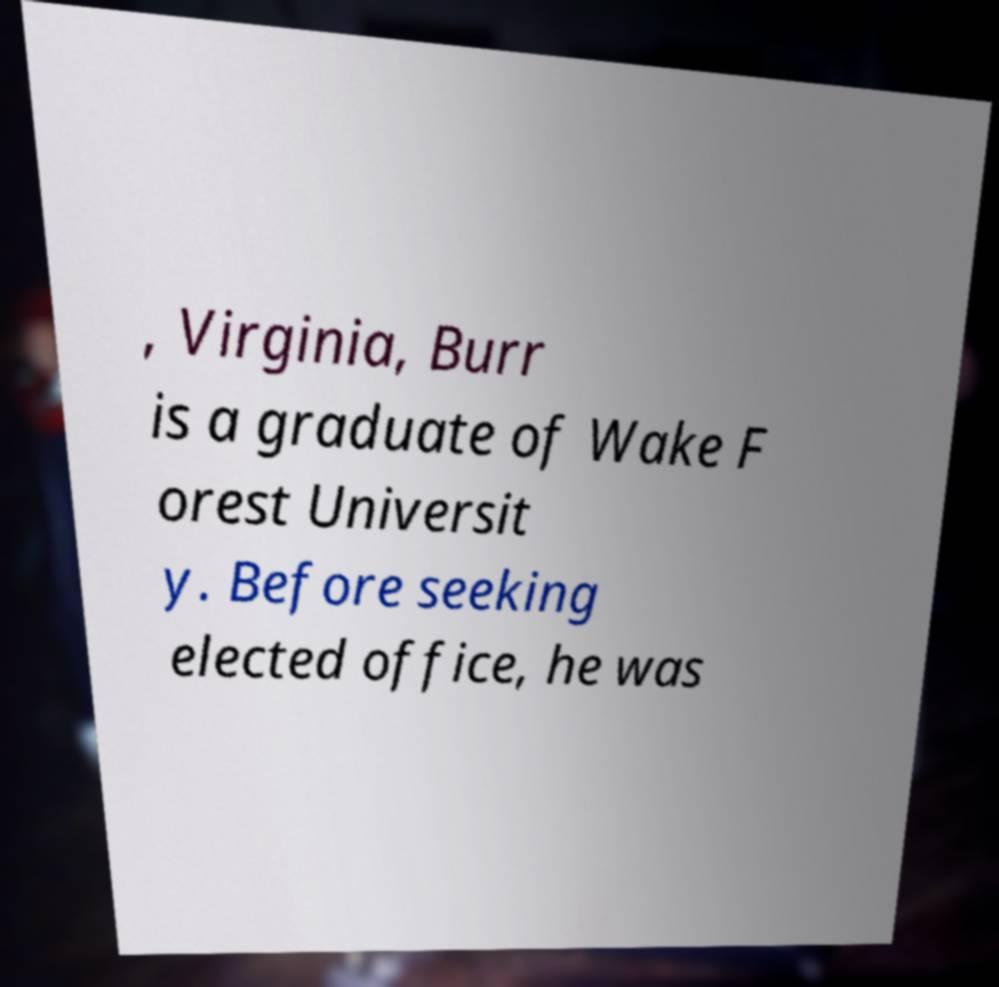Can you accurately transcribe the text from the provided image for me? , Virginia, Burr is a graduate of Wake F orest Universit y. Before seeking elected office, he was 